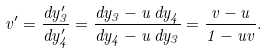<formula> <loc_0><loc_0><loc_500><loc_500>v ^ { \prime } = \frac { d y ^ { \prime } _ { 3 } } { d y ^ { \prime } _ { 4 } } = \frac { d y _ { 3 } - u \, d y _ { 4 } } { d y _ { 4 } - u \, d y _ { 3 } } = \frac { v - u } { 1 - u v } .</formula> 